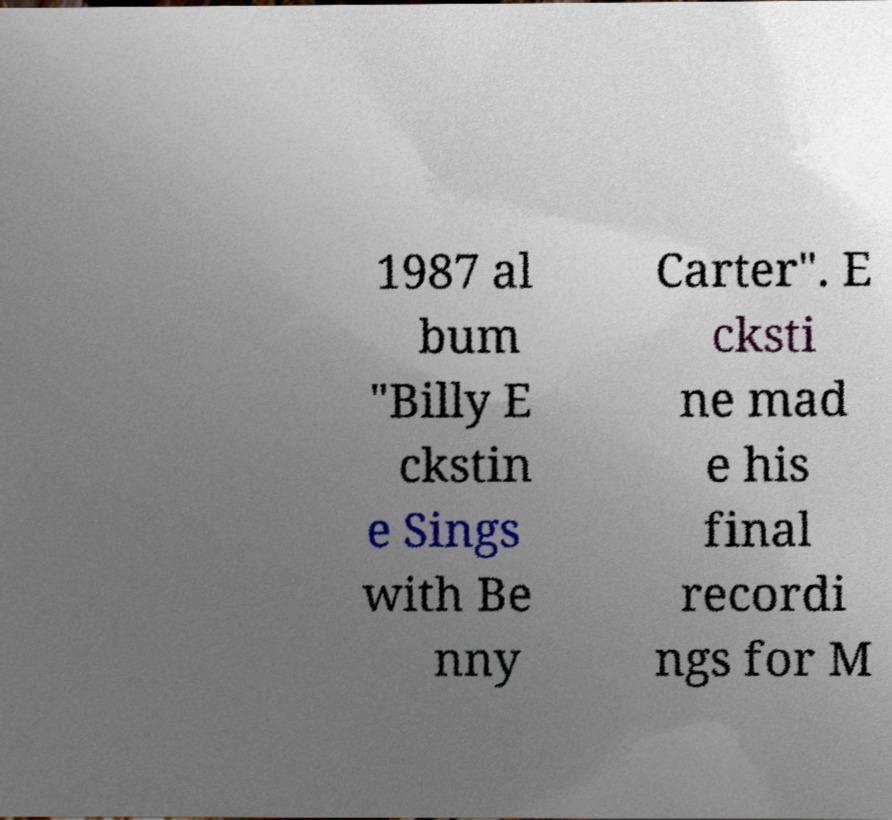Can you read and provide the text displayed in the image?This photo seems to have some interesting text. Can you extract and type it out for me? 1987 al bum "Billy E ckstin e Sings with Be nny Carter". E cksti ne mad e his final recordi ngs for M 